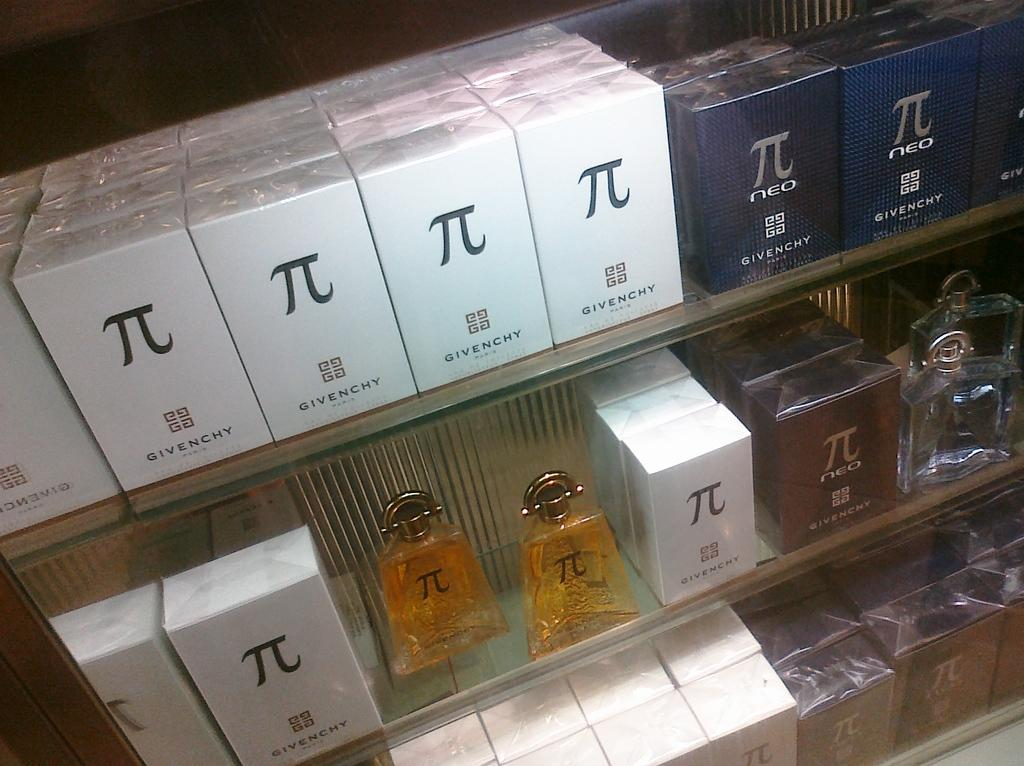<image>
Create a compact narrative representing the image presented. a box with the name Givenchy written on it 